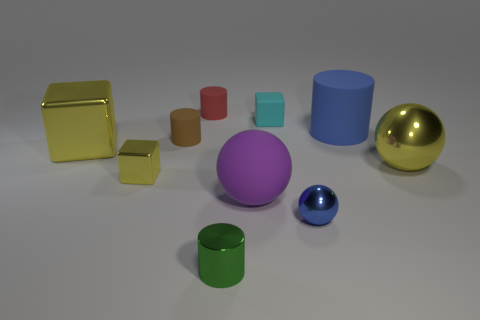How many other things are there of the same color as the small ball?
Make the answer very short. 1. Is the number of tiny yellow blocks in front of the metallic cylinder greater than the number of blue metallic objects?
Offer a terse response. No. What is the color of the large thing right of the cylinder to the right of the tiny sphere that is right of the small brown object?
Give a very brief answer. Yellow. Is the large yellow block made of the same material as the small sphere?
Make the answer very short. Yes. Is there a green ball of the same size as the blue matte cylinder?
Offer a terse response. No. What material is the yellow thing that is the same size as the red cylinder?
Offer a very short reply. Metal. Is there a big yellow thing that has the same shape as the small yellow thing?
Your answer should be compact. Yes. There is a tiny thing that is the same color as the large metallic ball; what material is it?
Give a very brief answer. Metal. There is a tiny rubber object on the left side of the red matte object; what shape is it?
Offer a very short reply. Cylinder. How many purple things are there?
Offer a very short reply. 1. 